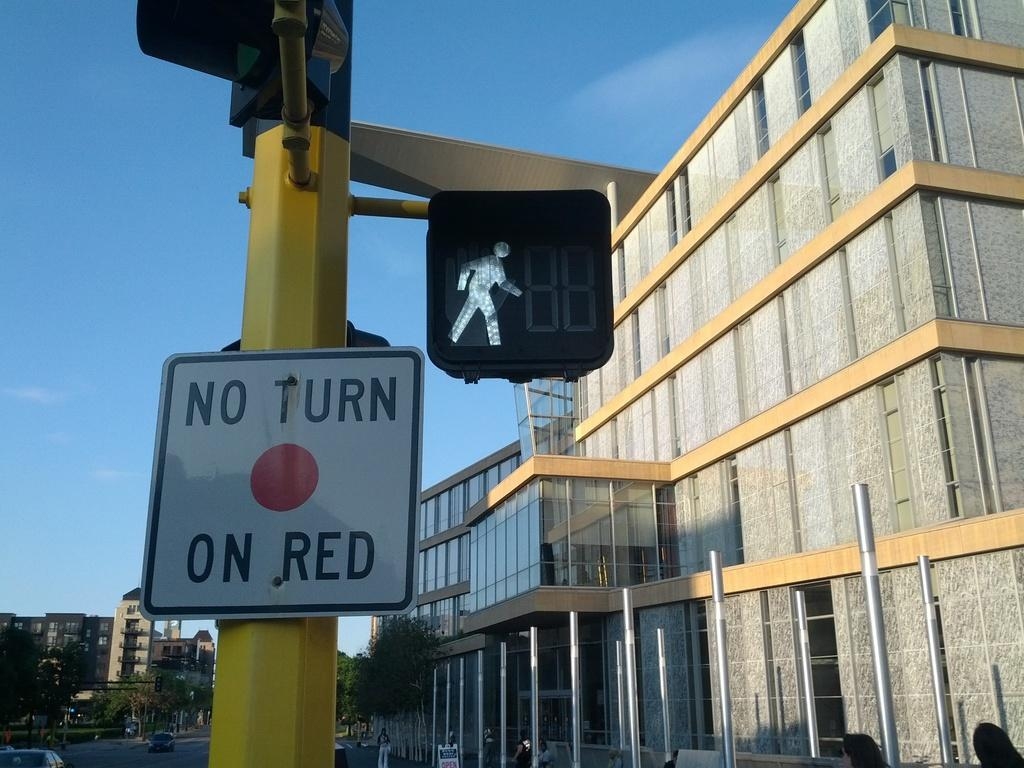<image>
Summarize the visual content of the image. A walk sign is lit up next to a No Turn on Red sign. 